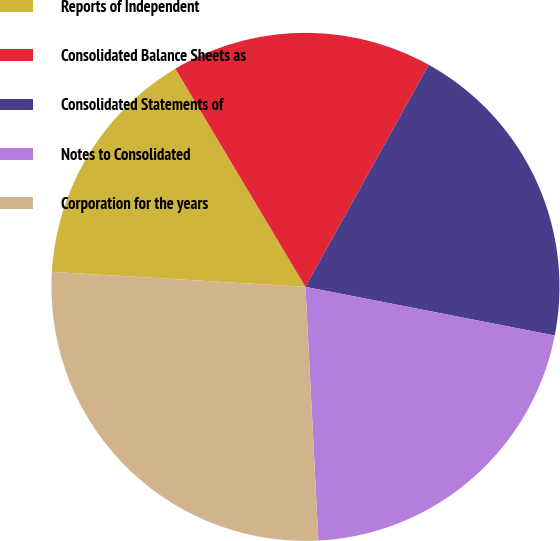Convert chart to OTSL. <chart><loc_0><loc_0><loc_500><loc_500><pie_chart><fcel>Reports of Independent<fcel>Consolidated Balance Sheets as<fcel>Consolidated Statements of<fcel>Notes to Consolidated<fcel>Corporation for the years<nl><fcel>15.5%<fcel>16.62%<fcel>20.0%<fcel>21.12%<fcel>26.75%<nl></chart> 